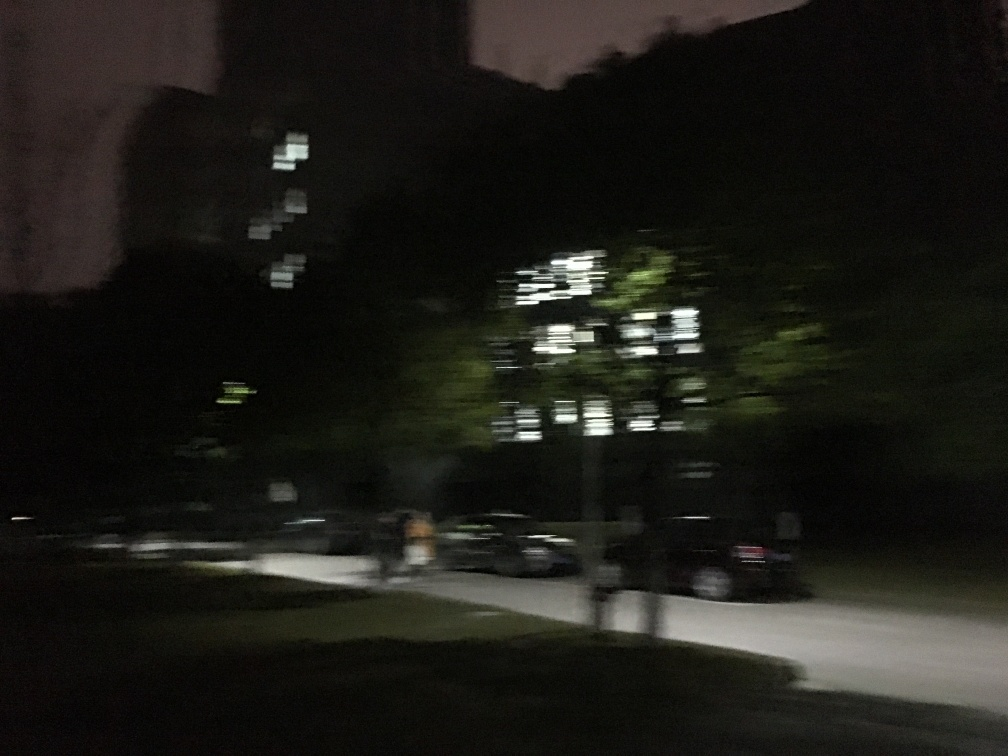What mood does this image evoke, and how could that mood be captured more effectively? The image evokes a mood of mystery and solitude, underscored by the darkness and the lone figure. To capture this mood more effectively, one might focus on composition by framing the solitary figure to create a sense of scale against the dark backdrop, using leading lines or the rule of thirds to guide the viewer's eye. Employing a selective focus technique to keep the figure sharp while allowing the surroundings to softly blur can emphasize the subject's isolation. Playing with light sources, such as street lamps or the available ambient light, to create contrast and dramatic shadows could also strengthen the moody quality of the shot. In post-processing, color grading to cooler tones would enhance the feeling of nighttime solitude. 